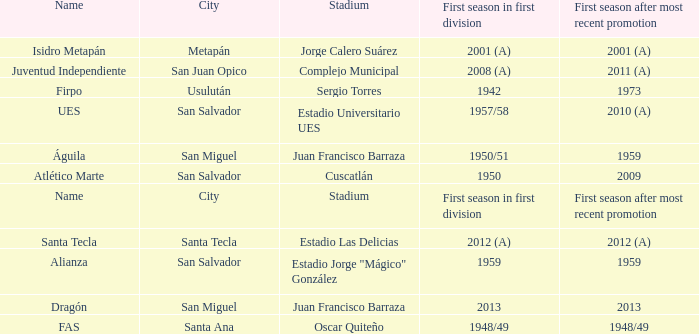Which city is Alianza? San Salvador. 